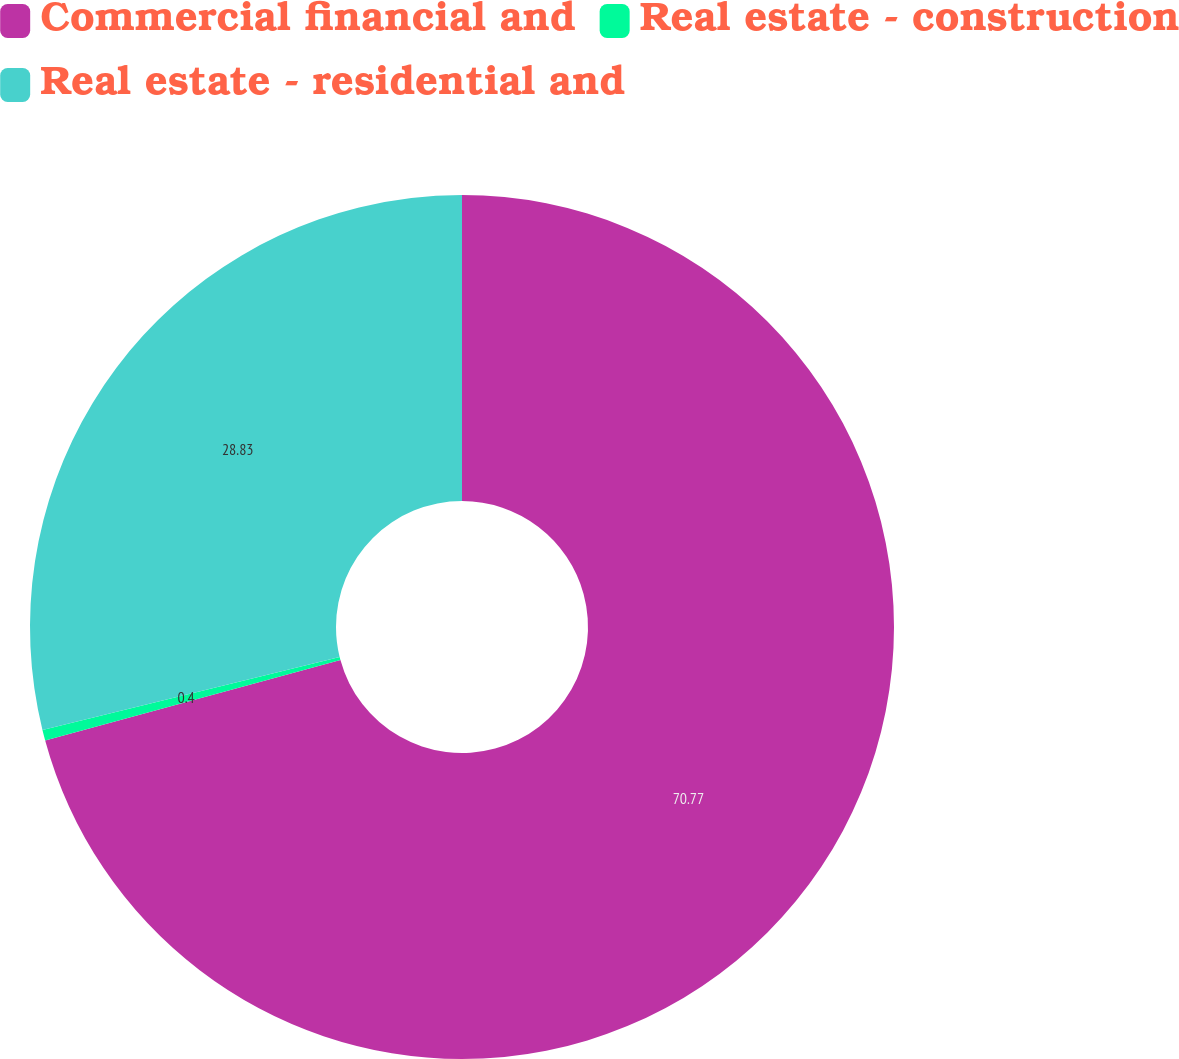<chart> <loc_0><loc_0><loc_500><loc_500><pie_chart><fcel>Commercial financial and<fcel>Real estate - construction<fcel>Real estate - residential and<nl><fcel>70.77%<fcel>0.4%<fcel>28.83%<nl></chart> 